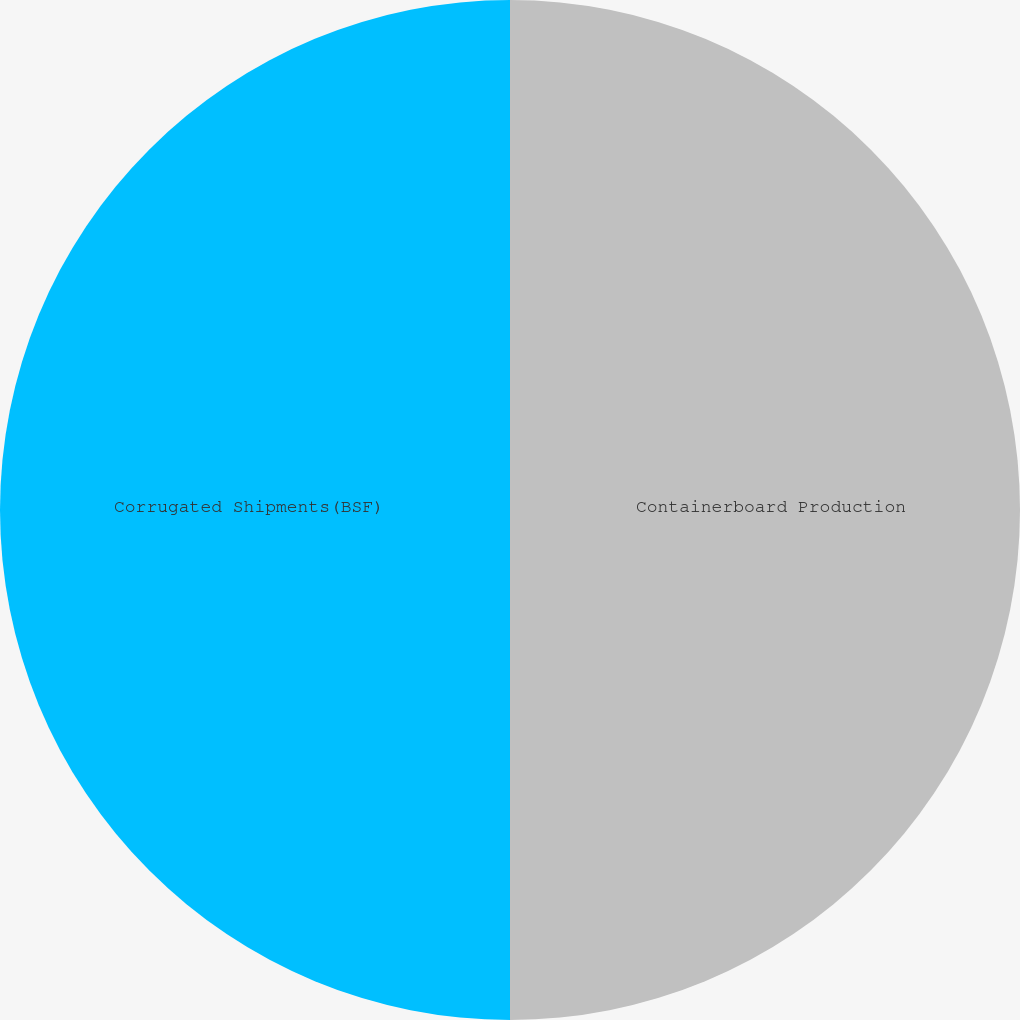<chart> <loc_0><loc_0><loc_500><loc_500><pie_chart><fcel>Containerboard Production<fcel>Corrugated Shipments(BSF)<nl><fcel>50.0%<fcel>50.0%<nl></chart> 